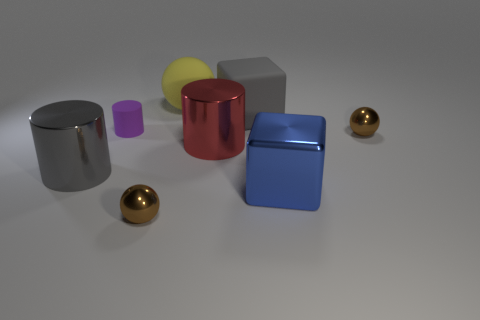There is a big matte block; is it the same color as the large shiny cylinder on the left side of the matte sphere?
Provide a short and direct response. Yes. Is there a small brown sphere in front of the small metallic ball on the left side of the cylinder right of the matte cylinder?
Make the answer very short. No. Are there fewer cylinders that are behind the big yellow thing than matte blocks?
Provide a short and direct response. Yes. What number of other objects are the same shape as the red metallic thing?
Ensure brevity in your answer.  2. What number of things are either cylinders that are in front of the tiny rubber cylinder or metallic balls that are behind the large gray metal cylinder?
Give a very brief answer. 3. What is the size of the ball that is left of the gray block and behind the large blue block?
Offer a terse response. Large. There is a large gray thing that is in front of the large red cylinder; is it the same shape as the big blue object?
Your answer should be very brief. No. How big is the red metallic cylinder that is behind the large cube that is in front of the gray object on the right side of the yellow sphere?
Your answer should be very brief. Large. What size is the metallic object that is the same color as the rubber block?
Ensure brevity in your answer.  Large. How many things are small shiny objects or metal cylinders?
Make the answer very short. 4. 